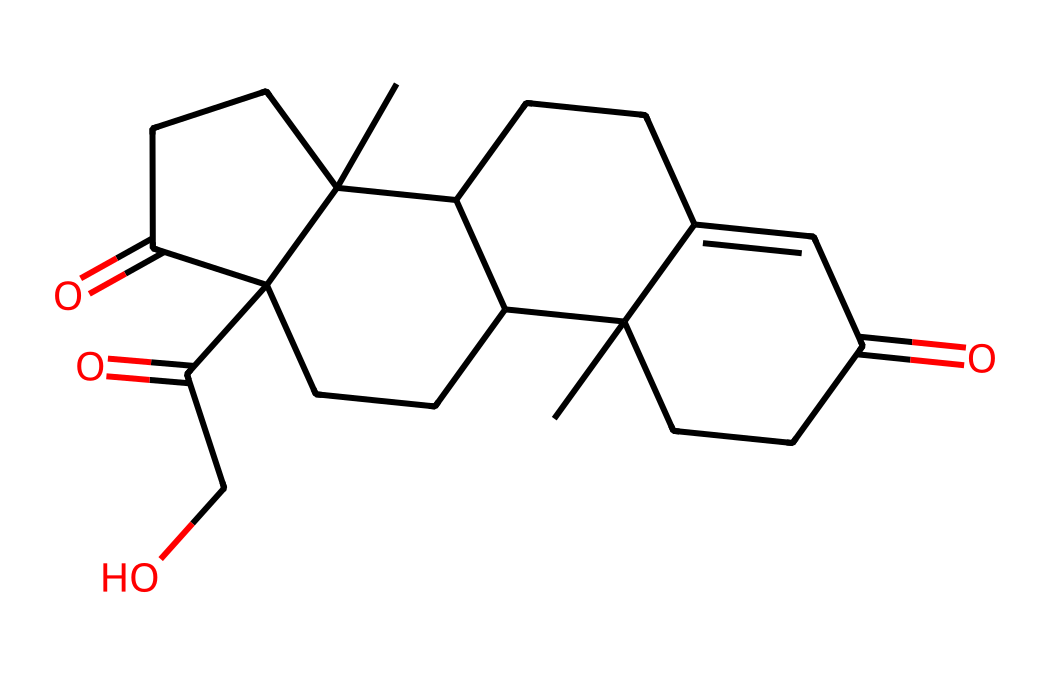What is the chemical name of this structure? The SMILES representation refers to cortisol, which is a well-known hormone involved in stress response. This can be identified due to the specific arrangement of rings and functional groups present in the structure.
Answer: cortisol How many carbon atoms are in cortisol's structure? By analyzing the SMILES representation, we can count the number of "C" characters, which represent carbon atoms. There are 21 carbon atoms in the structure.
Answer: 21 What type of functional groups are present in cortisol? Looking at the SMILES, we see the presence of ketone groups (=O) and a hydroxyl group (O). These functional groups are typical for steroid hormones like cortisol.
Answer: ketone and hydroxyl Does cortisol contain any double bonds? In the given structure, we can see that there are double bonds as indicated by "=" in the SMILES representation, showing the presence of unsaturation in the molecule.
Answer: yes What is the molecular formula of cortisol? From the SMILES, we can determine that cortisol's molecular formula is C21H30O5, which indicates the number of each type of atom present in the molecule.
Answer: C21H30O5 How does the structure of cortisol contribute to its function as a hormone? The cyclic structure with various functional groups enables cortisol to interact with specific receptors in the body, important for regulating metabolism and stress response. The hydrophobic nature and size of the molecule allow it to cross cell membranes easily.
Answer: cyclic structure and functional groups 